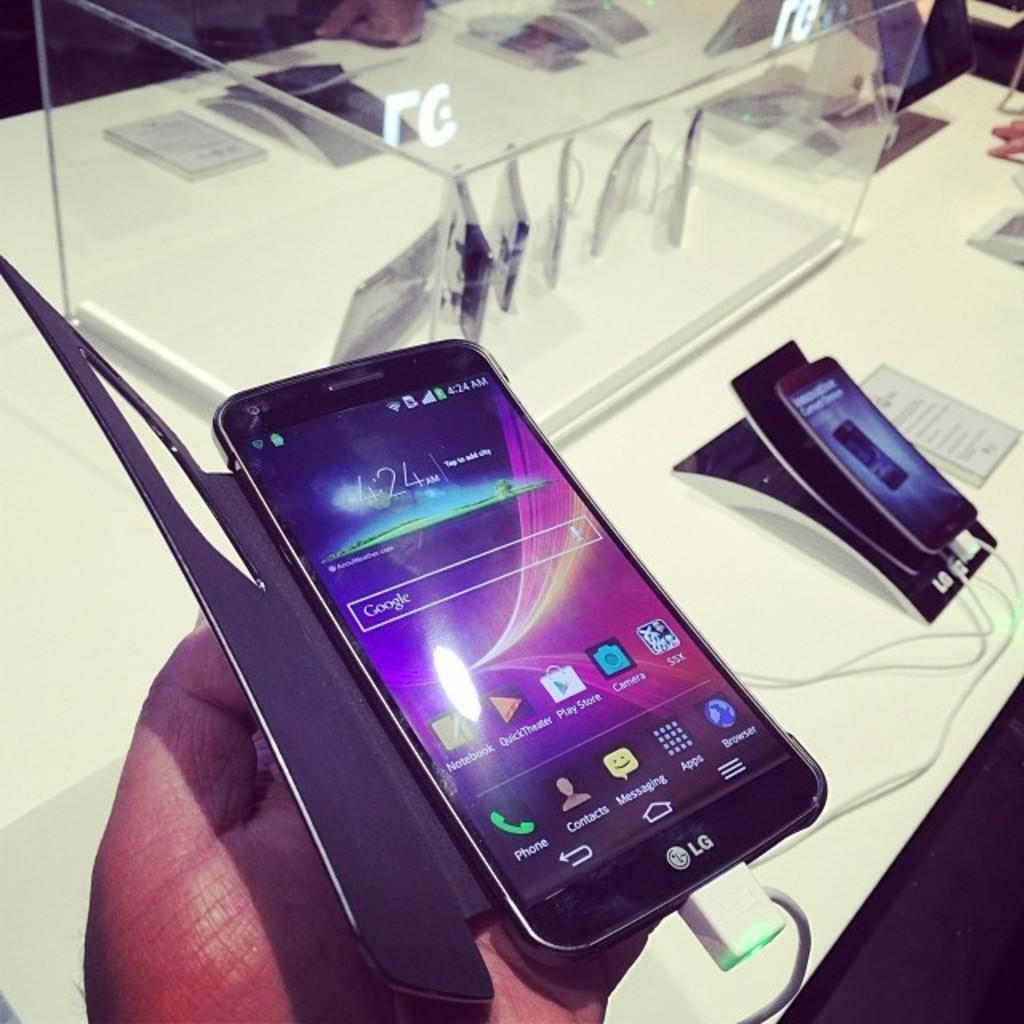<image>
Describe the image concisely. LG Cell Phone with the time of 4:24 displayed. 